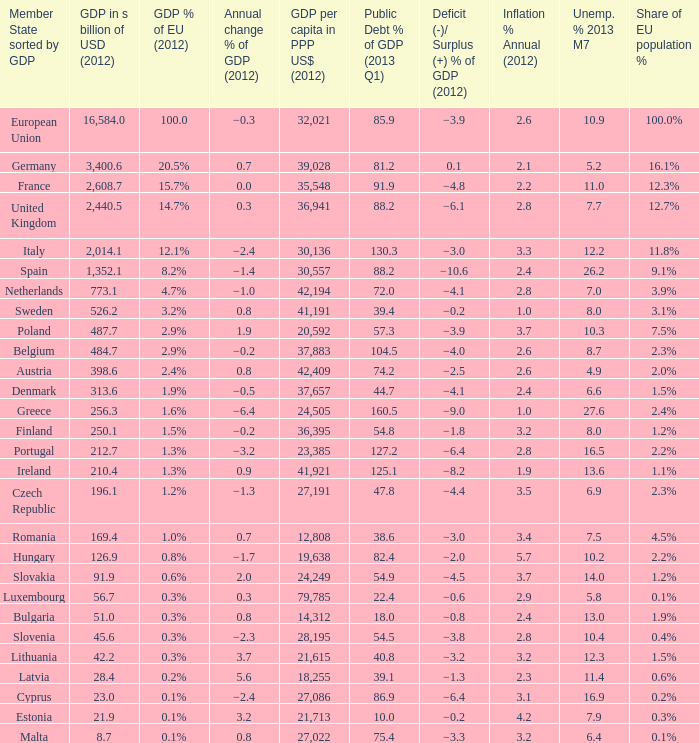What is the deficit/surplus % of the 2012 GDP of the country with a GDP in billions of USD in 2012 less than 1,352.1, a GDP per capita in PPP US dollars in 2012 greater than 21,615, public debt % of GDP in the 2013 Q1 less than 75.4, and an inflation % annual in 2012 of 2.9? −0.6. 